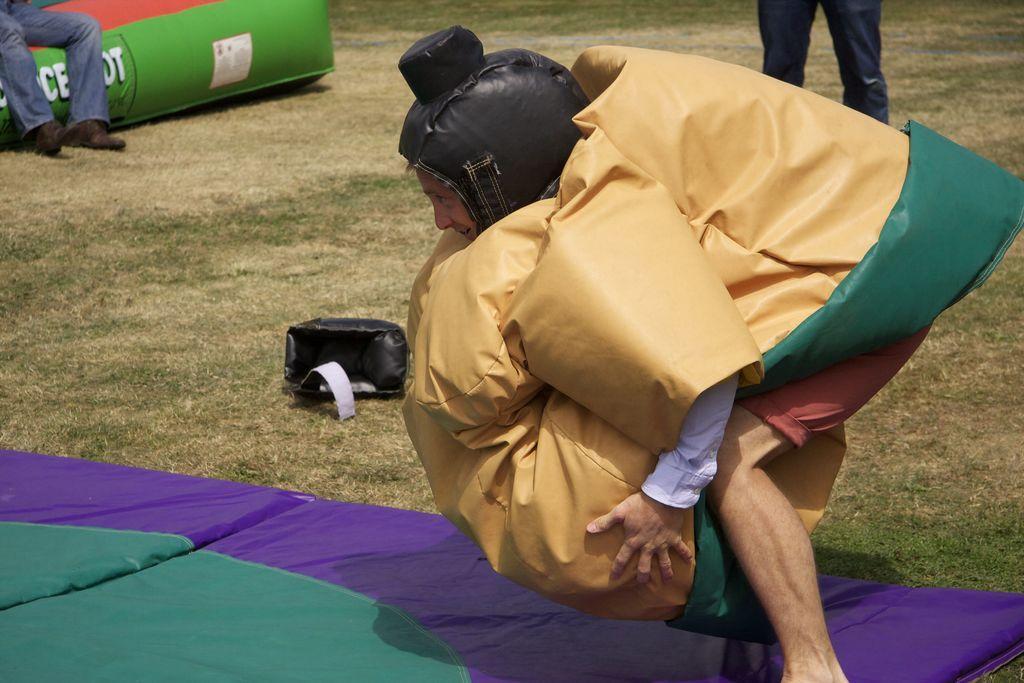Describe this image in one or two sentences. In the picture there is a person doing some activity and there is a bed sheet below the legs of the person, beside that there is a lot of grass and there are two legs of two people are visible in the image. 